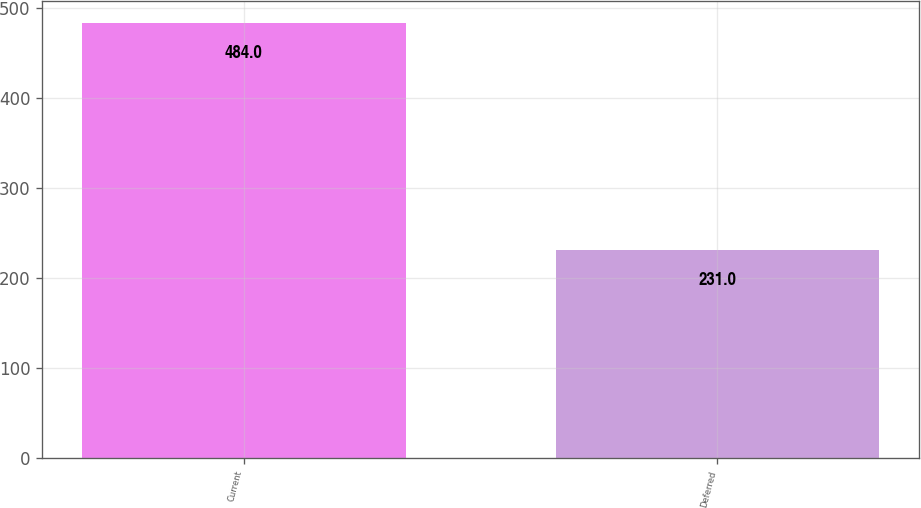<chart> <loc_0><loc_0><loc_500><loc_500><bar_chart><fcel>Current<fcel>Deferred<nl><fcel>484<fcel>231<nl></chart> 